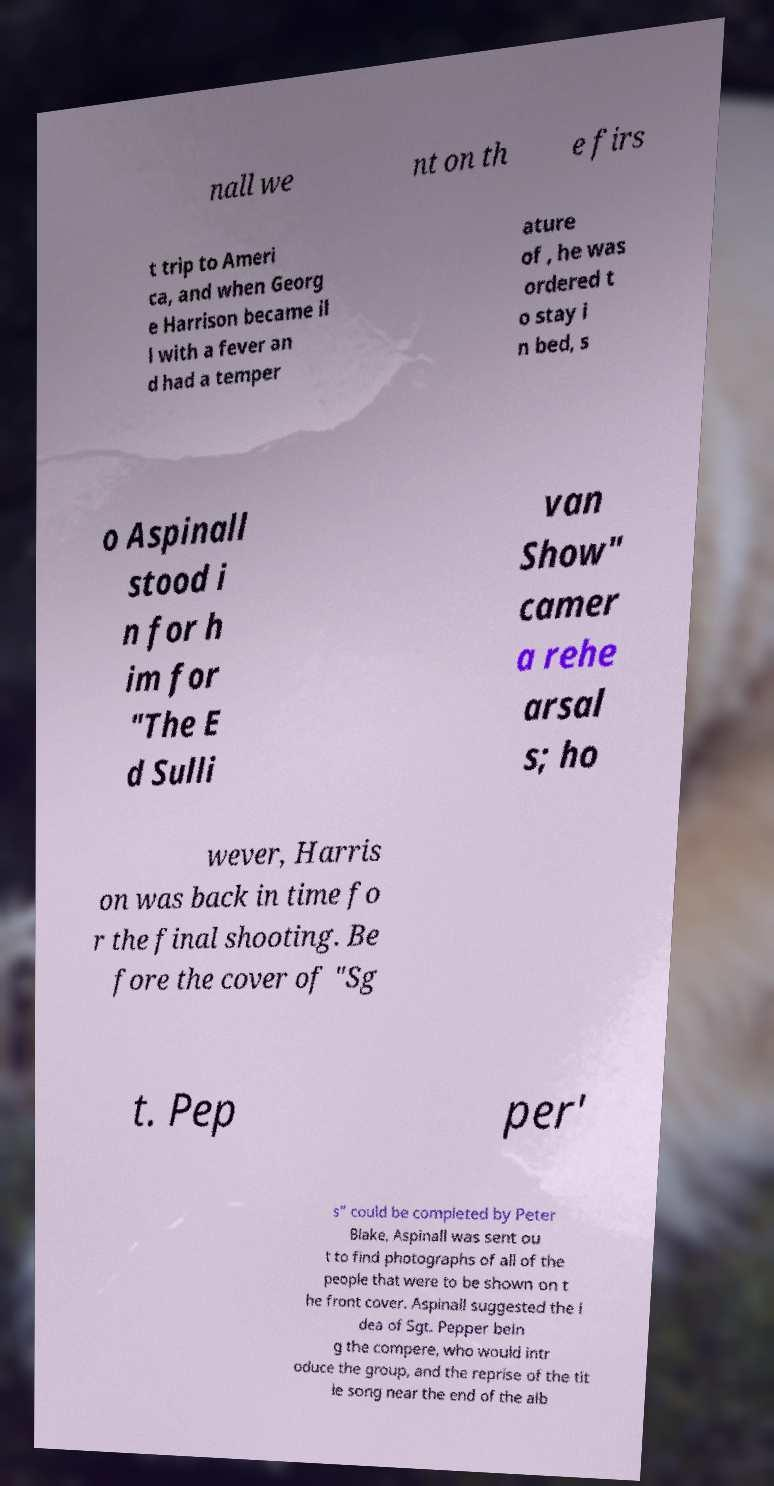Please read and relay the text visible in this image. What does it say? nall we nt on th e firs t trip to Ameri ca, and when Georg e Harrison became il l with a fever an d had a temper ature of , he was ordered t o stay i n bed, s o Aspinall stood i n for h im for "The E d Sulli van Show" camer a rehe arsal s; ho wever, Harris on was back in time fo r the final shooting. Be fore the cover of "Sg t. Pep per' s" could be completed by Peter Blake, Aspinall was sent ou t to find photographs of all of the people that were to be shown on t he front cover. Aspinall suggested the i dea of Sgt. Pepper bein g the compere, who would intr oduce the group, and the reprise of the tit le song near the end of the alb 